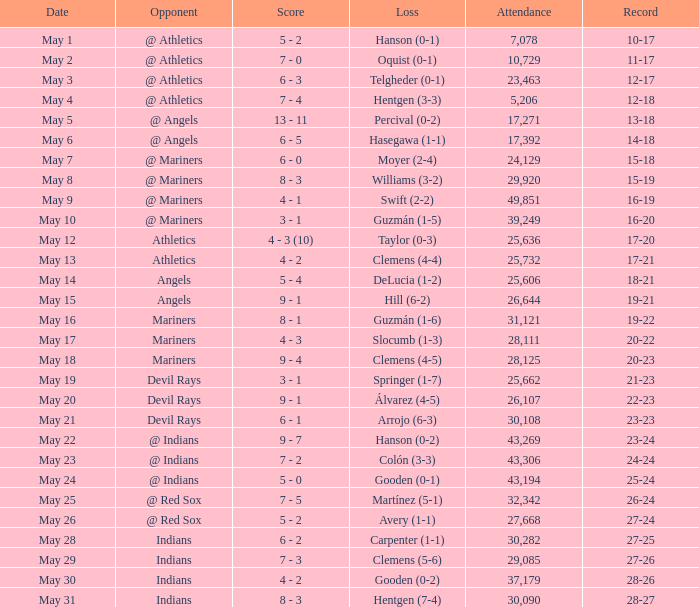When did the 27-25 record occur? May 28. 